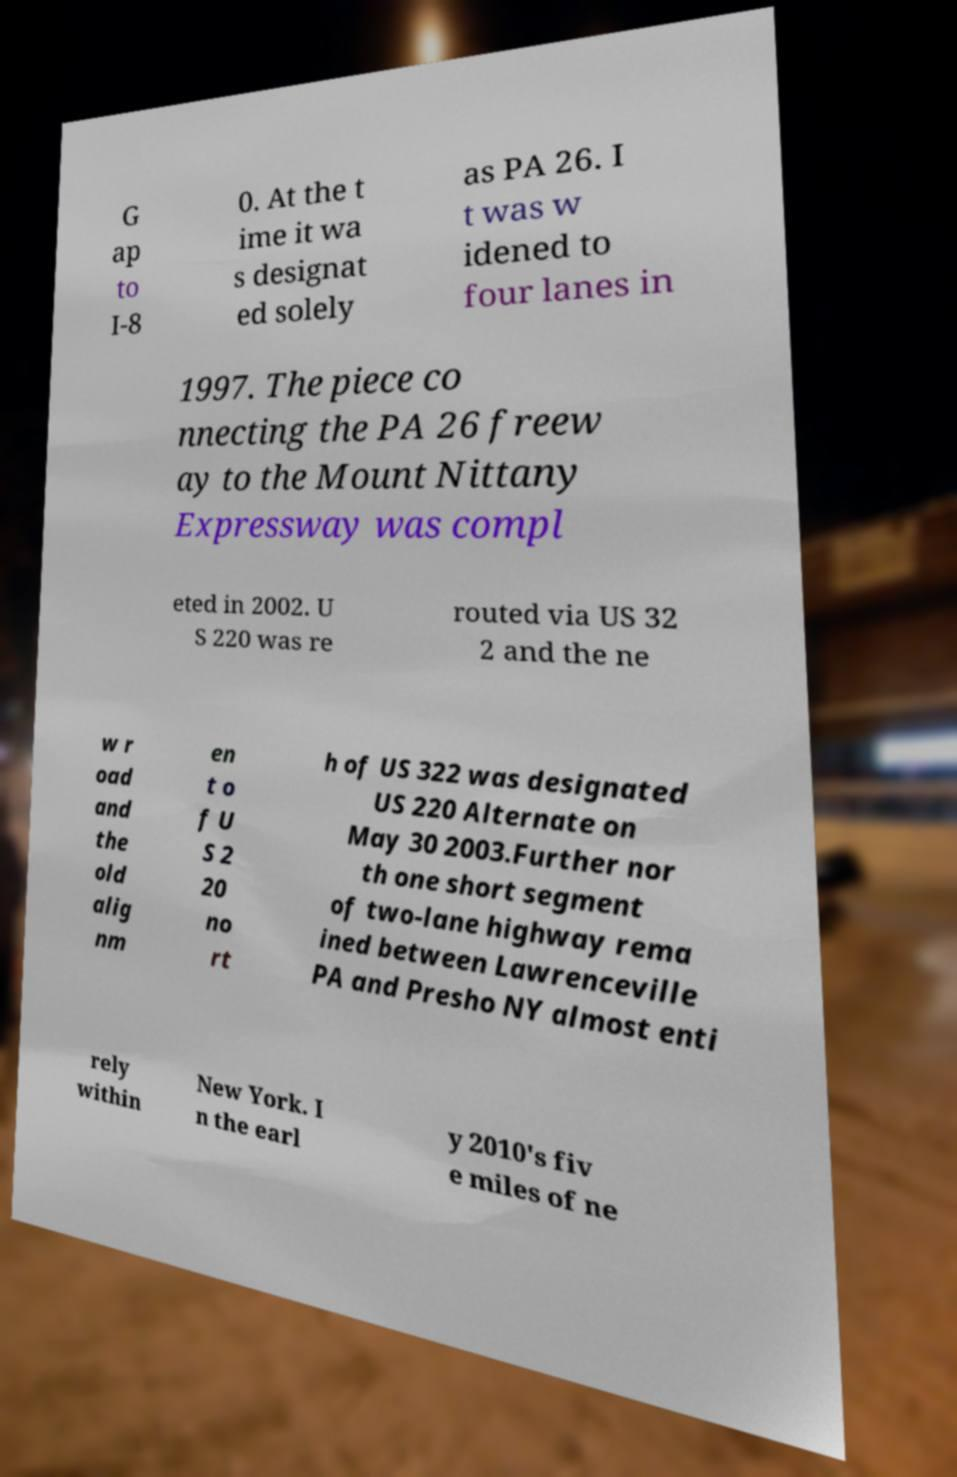Can you accurately transcribe the text from the provided image for me? G ap to I-8 0. At the t ime it wa s designat ed solely as PA 26. I t was w idened to four lanes in 1997. The piece co nnecting the PA 26 freew ay to the Mount Nittany Expressway was compl eted in 2002. U S 220 was re routed via US 32 2 and the ne w r oad and the old alig nm en t o f U S 2 20 no rt h of US 322 was designated US 220 Alternate on May 30 2003.Further nor th one short segment of two-lane highway rema ined between Lawrenceville PA and Presho NY almost enti rely within New York. I n the earl y 2010's fiv e miles of ne 